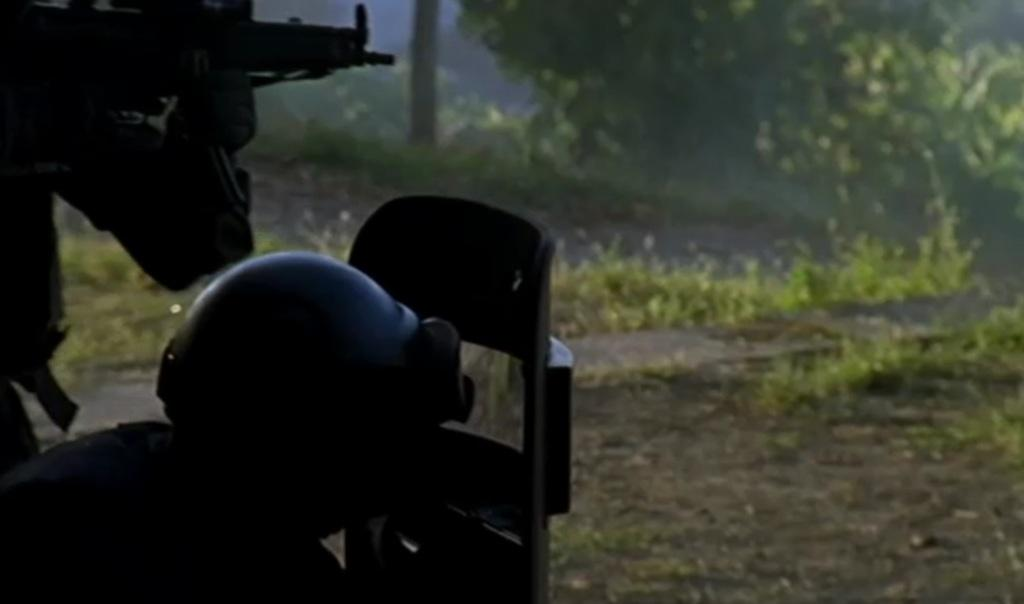What is the overall lighting condition in the image? The image is dark in some parts. What protective gear is visible in the image? There is a helmet in the image. What defensive equipment is present in the image? There is a shield in the image. What weapon can be seen in the image? There is a gun in the image. What type of vegetation is present in the image? There is grass and plants in the image. What type of terrain is visible in the image? There is mud in the image. Can you see a tiger walking through the grass in the image? No, there is no tiger present in the image. What type of food is the cook preparing in the image? There is no cook or food preparation visible in the image. 